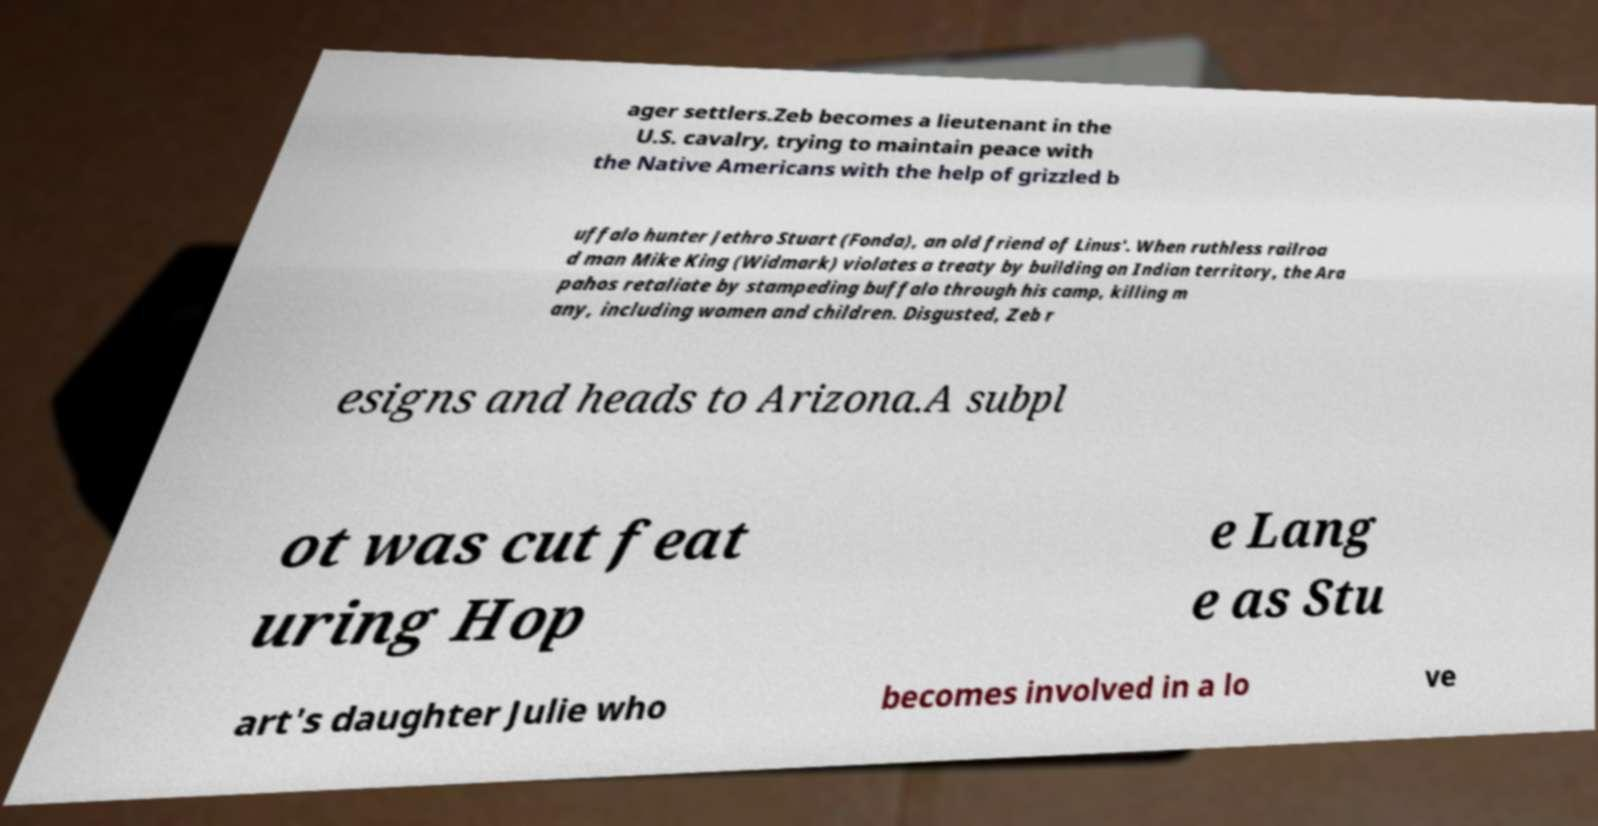Please read and relay the text visible in this image. What does it say? ager settlers.Zeb becomes a lieutenant in the U.S. cavalry, trying to maintain peace with the Native Americans with the help of grizzled b uffalo hunter Jethro Stuart (Fonda), an old friend of Linus'. When ruthless railroa d man Mike King (Widmark) violates a treaty by building on Indian territory, the Ara pahos retaliate by stampeding buffalo through his camp, killing m any, including women and children. Disgusted, Zeb r esigns and heads to Arizona.A subpl ot was cut feat uring Hop e Lang e as Stu art's daughter Julie who becomes involved in a lo ve 